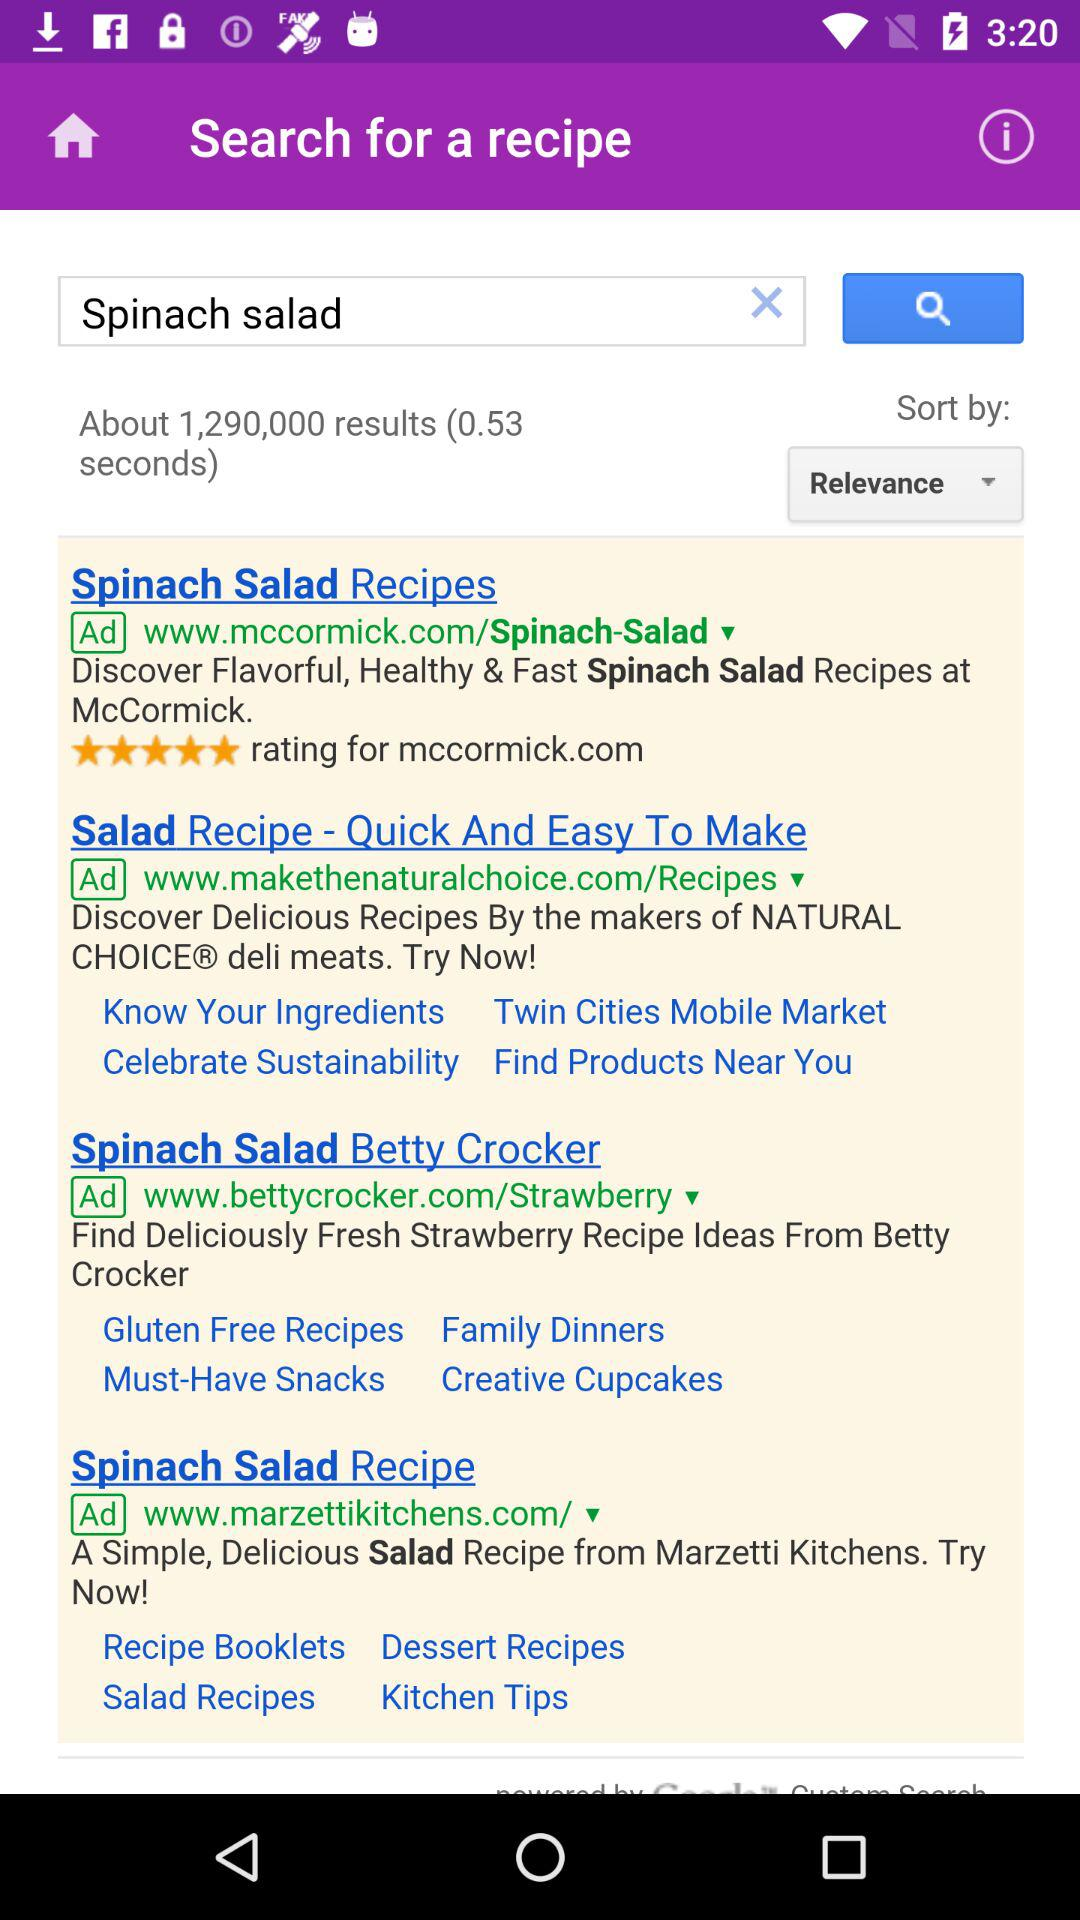How many results are there for the search term 'Spinach salad'?
Answer the question using a single word or phrase. 1,290,000 